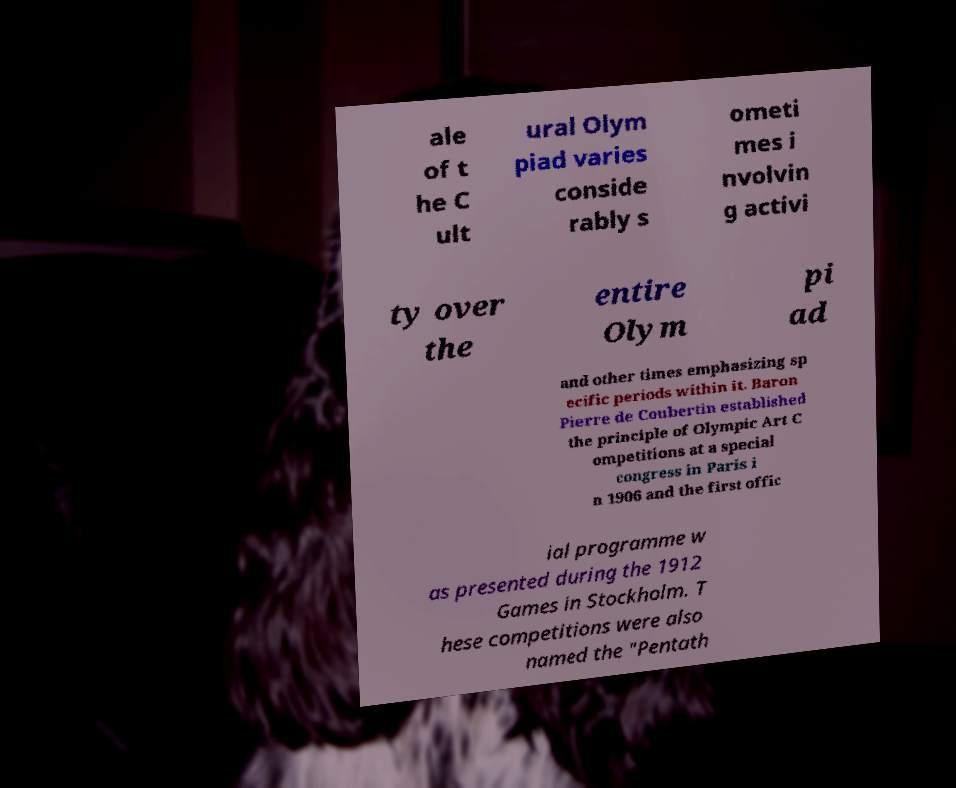There's text embedded in this image that I need extracted. Can you transcribe it verbatim? ale of t he C ult ural Olym piad varies conside rably s ometi mes i nvolvin g activi ty over the entire Olym pi ad and other times emphasizing sp ecific periods within it. Baron Pierre de Coubertin established the principle of Olympic Art C ompetitions at a special congress in Paris i n 1906 and the first offic ial programme w as presented during the 1912 Games in Stockholm. T hese competitions were also named the "Pentath 